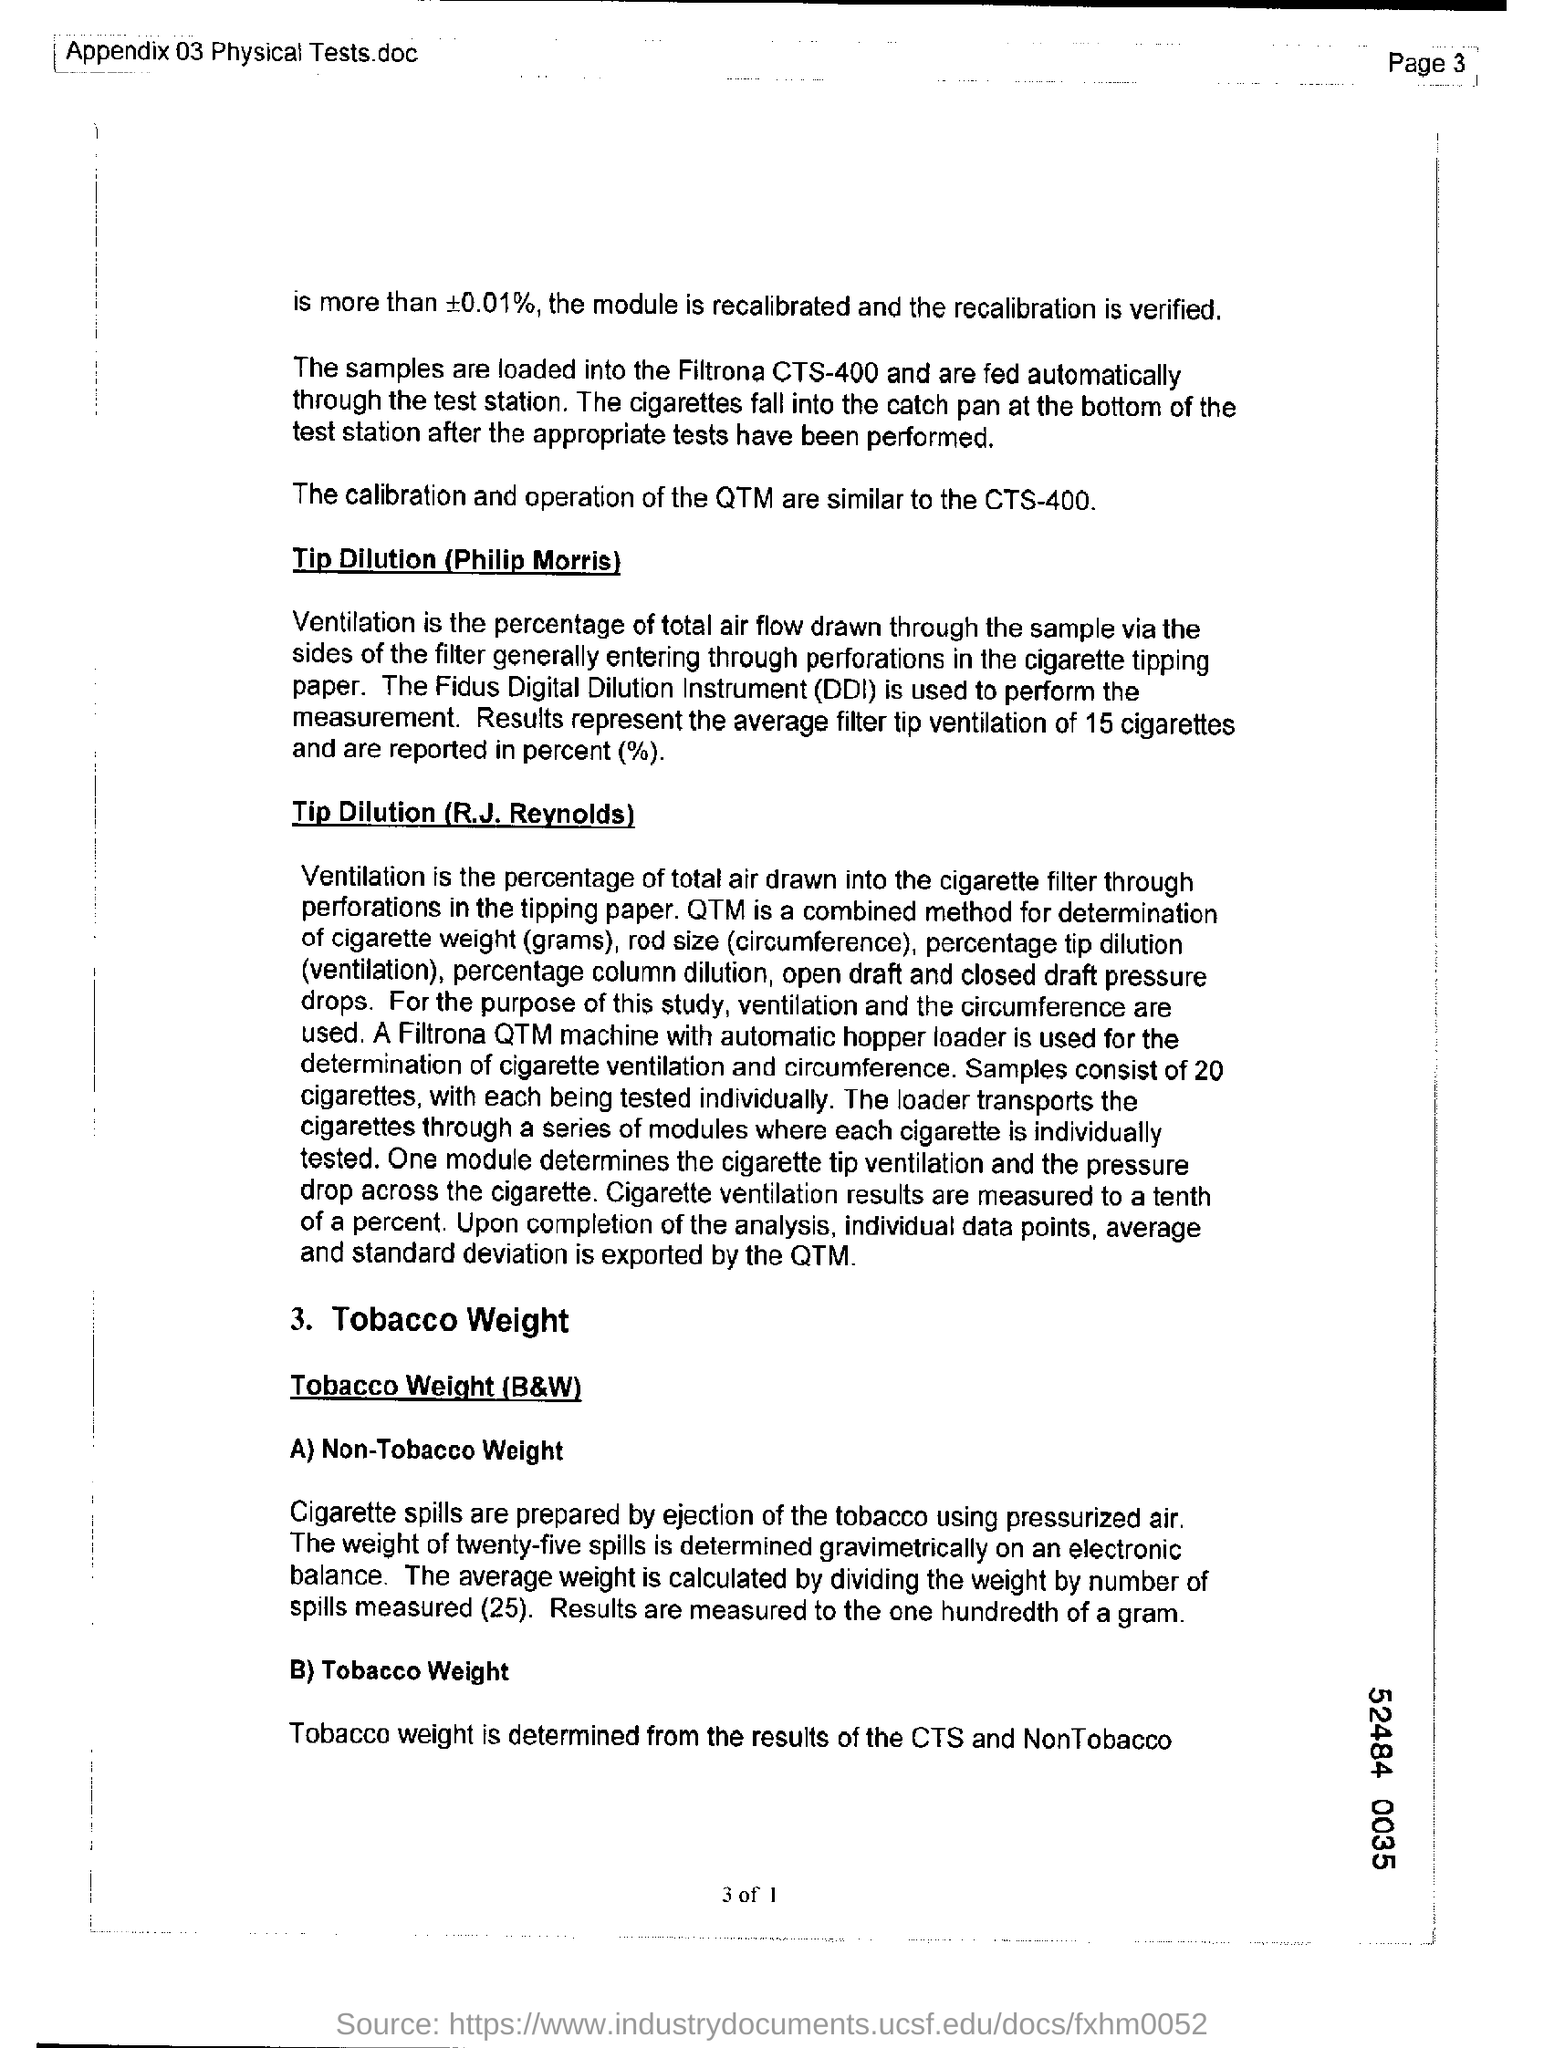Point out several critical features in this image. Digital Dilution Instrument, commonly abbreviated as DDI, is a device used to measure the concentration of a solution. 